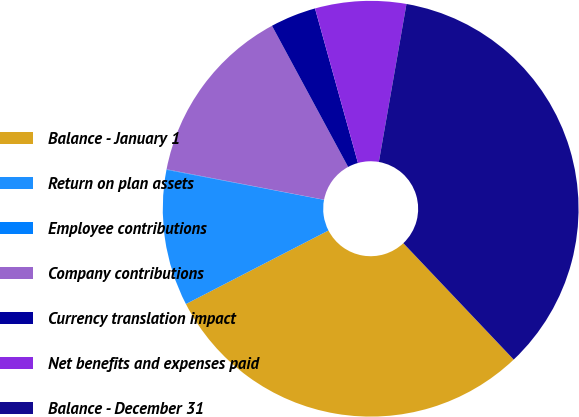Convert chart. <chart><loc_0><loc_0><loc_500><loc_500><pie_chart><fcel>Balance - January 1<fcel>Return on plan assets<fcel>Employee contributions<fcel>Company contributions<fcel>Currency translation impact<fcel>Net benefits and expenses paid<fcel>Balance - December 31<nl><fcel>29.5%<fcel>10.58%<fcel>0.04%<fcel>14.09%<fcel>3.56%<fcel>7.07%<fcel>35.17%<nl></chart> 